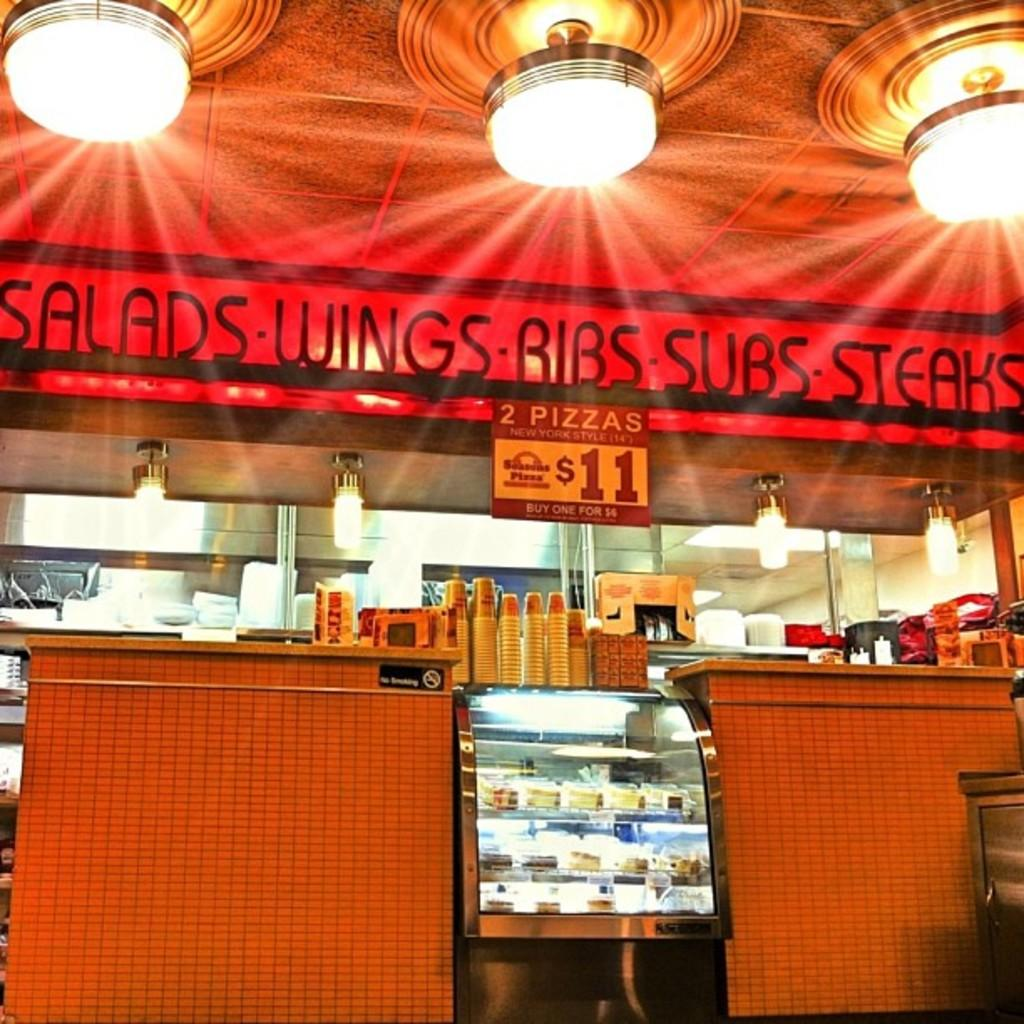<image>
Render a clear and concise summary of the photo. Salads,Ribs,Subs,wings banner hung above a fast food stand with a flyer that says 2 pizzas for eleven dollars. 